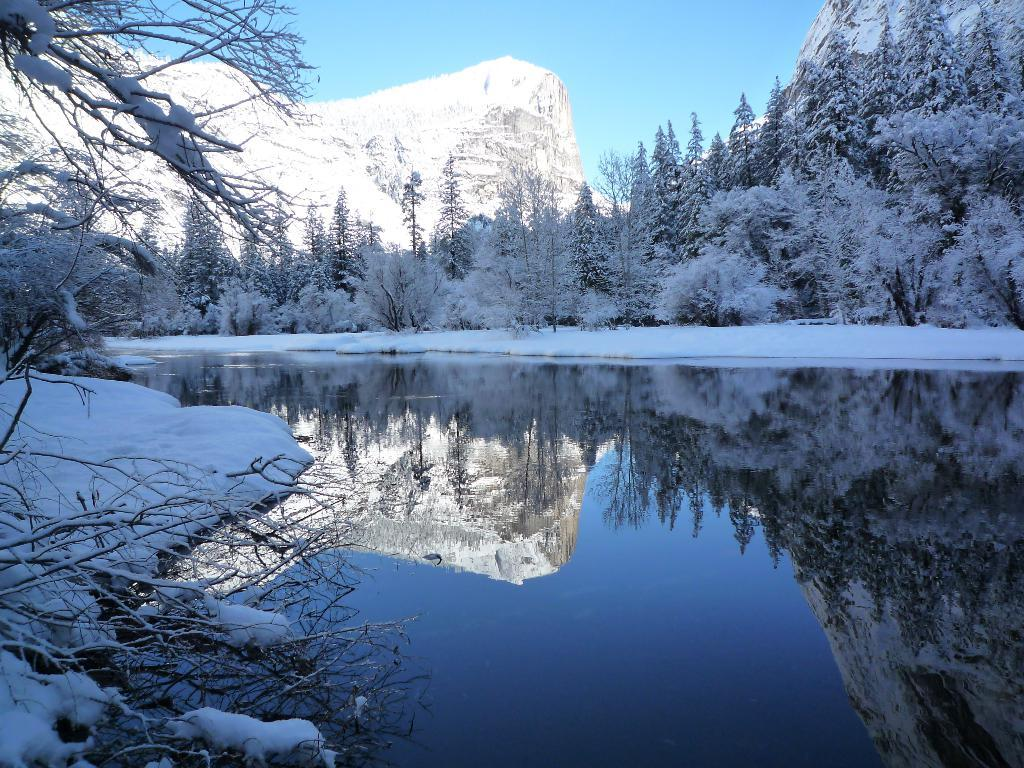What type of vegetation is present in the image? There are trees in the image. What geographical feature can be seen in the image? There is a hill in the image. What is the weather condition in the image? There is snow on the hill and trees, indicating a snowy condition. What body of water is visible in the image? There is water visible in the image. What is the color of the sky in the image? The sky is blue in the image. What is reflected in the water? The reflection of trees and the hill can be seen in the water. Can you tell me how many men are teaching in the image? There are no men or teaching activities present in the image. How many ducks are swimming in the water in the image? There are no ducks visible in the image; only trees, a hill, and water are present. 